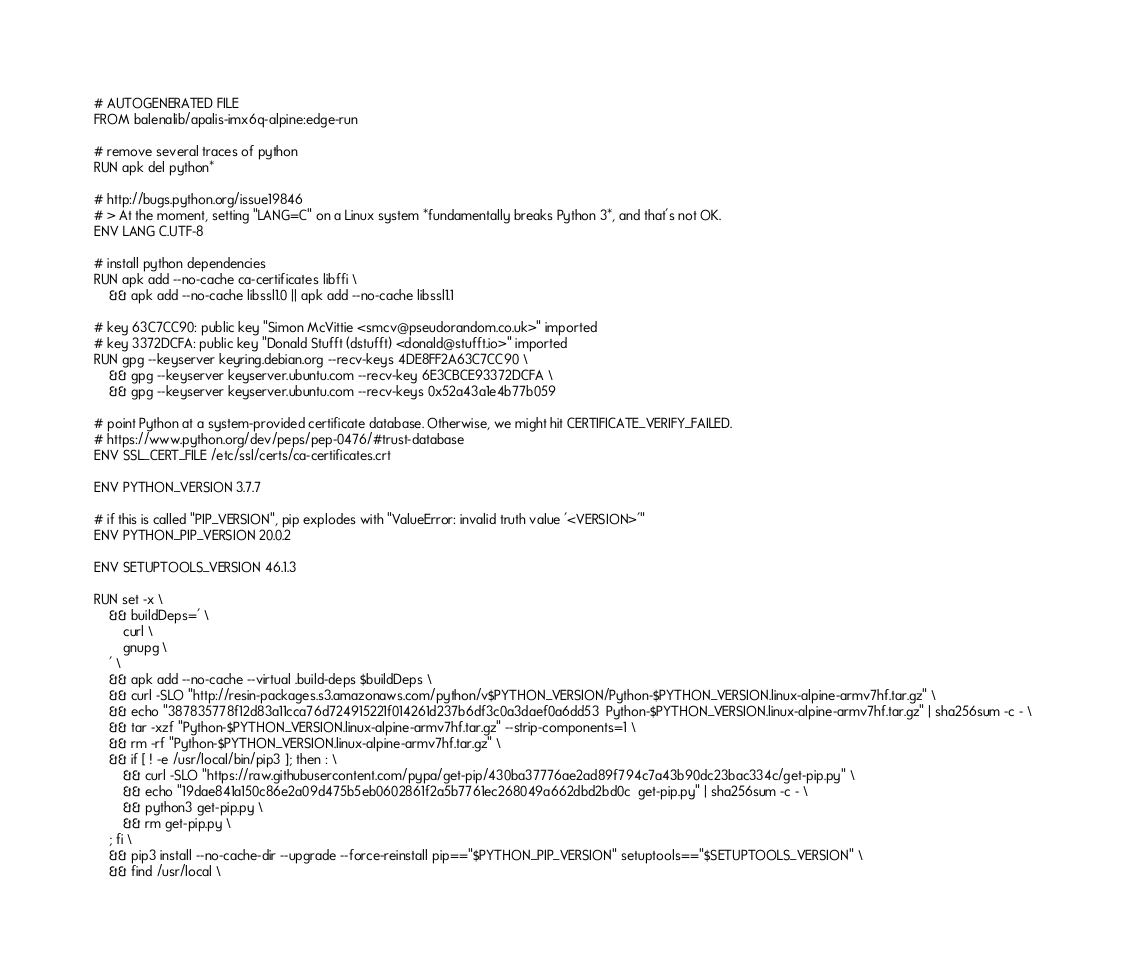<code> <loc_0><loc_0><loc_500><loc_500><_Dockerfile_># AUTOGENERATED FILE
FROM balenalib/apalis-imx6q-alpine:edge-run

# remove several traces of python
RUN apk del python*

# http://bugs.python.org/issue19846
# > At the moment, setting "LANG=C" on a Linux system *fundamentally breaks Python 3*, and that's not OK.
ENV LANG C.UTF-8

# install python dependencies
RUN apk add --no-cache ca-certificates libffi \
	&& apk add --no-cache libssl1.0 || apk add --no-cache libssl1.1

# key 63C7CC90: public key "Simon McVittie <smcv@pseudorandom.co.uk>" imported
# key 3372DCFA: public key "Donald Stufft (dstufft) <donald@stufft.io>" imported
RUN gpg --keyserver keyring.debian.org --recv-keys 4DE8FF2A63C7CC90 \
	&& gpg --keyserver keyserver.ubuntu.com --recv-key 6E3CBCE93372DCFA \
	&& gpg --keyserver keyserver.ubuntu.com --recv-keys 0x52a43a1e4b77b059

# point Python at a system-provided certificate database. Otherwise, we might hit CERTIFICATE_VERIFY_FAILED.
# https://www.python.org/dev/peps/pep-0476/#trust-database
ENV SSL_CERT_FILE /etc/ssl/certs/ca-certificates.crt

ENV PYTHON_VERSION 3.7.7

# if this is called "PIP_VERSION", pip explodes with "ValueError: invalid truth value '<VERSION>'"
ENV PYTHON_PIP_VERSION 20.0.2

ENV SETUPTOOLS_VERSION 46.1.3

RUN set -x \
	&& buildDeps=' \
		curl \
		gnupg \
	' \
	&& apk add --no-cache --virtual .build-deps $buildDeps \
	&& curl -SLO "http://resin-packages.s3.amazonaws.com/python/v$PYTHON_VERSION/Python-$PYTHON_VERSION.linux-alpine-armv7hf.tar.gz" \
	&& echo "387835778f12d83a11cca76d724915221f014261d237b6df3c0a3daef0a6dd53  Python-$PYTHON_VERSION.linux-alpine-armv7hf.tar.gz" | sha256sum -c - \
	&& tar -xzf "Python-$PYTHON_VERSION.linux-alpine-armv7hf.tar.gz" --strip-components=1 \
	&& rm -rf "Python-$PYTHON_VERSION.linux-alpine-armv7hf.tar.gz" \
	&& if [ ! -e /usr/local/bin/pip3 ]; then : \
		&& curl -SLO "https://raw.githubusercontent.com/pypa/get-pip/430ba37776ae2ad89f794c7a43b90dc23bac334c/get-pip.py" \
		&& echo "19dae841a150c86e2a09d475b5eb0602861f2a5b7761ec268049a662dbd2bd0c  get-pip.py" | sha256sum -c - \
		&& python3 get-pip.py \
		&& rm get-pip.py \
	; fi \
	&& pip3 install --no-cache-dir --upgrade --force-reinstall pip=="$PYTHON_PIP_VERSION" setuptools=="$SETUPTOOLS_VERSION" \
	&& find /usr/local \</code> 